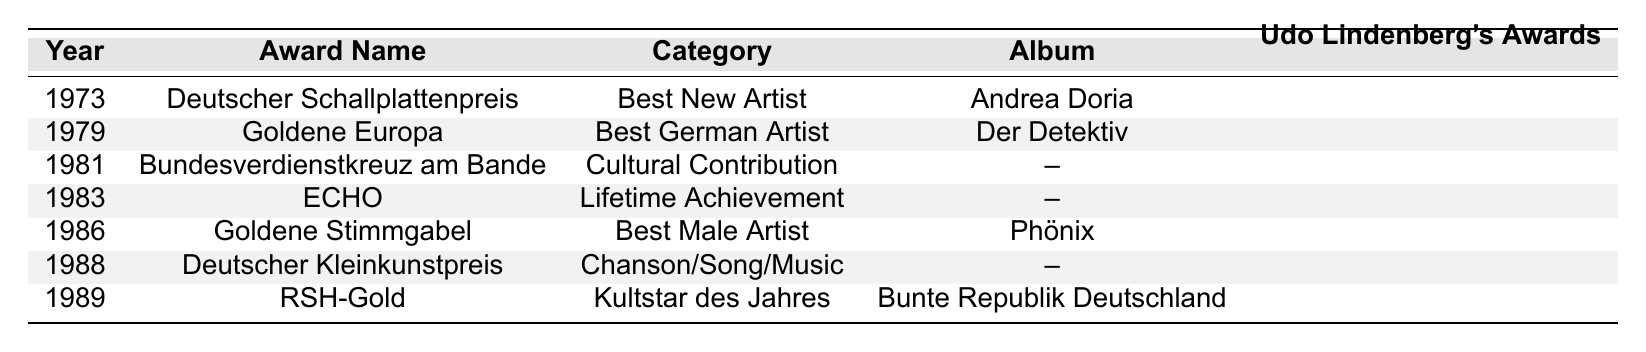What award did Udo Lindenberg receive in 1973? According to the table, in 1973, Udo Lindenberg received the "Deutscher Schallplattenpreis" for "Best New Artist."
Answer: Deutscher Schallplattenpreis How many awards did Udo Lindenberg receive in the 1980s? The table lists Udo Lindenberg receiving four awards in the 1980s: 1981 (Bundesverdienstkreuz am Bande), 1983 (ECHO), 1986 (Goldene Stimmgabel), and 1988 (Deutscher Kleinkunstpreis).
Answer: Four awards Which award did Udo Lindenberg win for the album "Bunte Republik Deutschland"? Udo Lindenberg received the "RSH-Gold" for "Kultstar des Jahres" in 1989 for the album "Bunte Republik Deutschland."
Answer: RSH-Gold What is the category of the award received in 1986? The award received in 1986 is the "Goldene Stimmgabel" under the category "Best Male Artist."
Answer: Best Male Artist In which year did Udo Lindenberg receive an award for "Cultural Contribution"? Udo Lindenberg received an award for "Cultural Contribution" in 1981, specifically the "Bundesverdienstkreuz am Bande."
Answer: 1981 How many awards did Udo Lindenberg win for specific albums until 1990? Udo Lindenberg won awards for three specific albums: "Andrea Doria" (1973), "Der Detektiv" (1979), and "Phönix" (1986), totaling three albums.
Answer: Three albums Was there any award in 1988, and if so, what was it for? Yes, in 1988, Udo Lindenberg received the "Deutscher Kleinkunstpreis" for the category "Chanson/Song/Music."
Answer: Yes, Deutscher Kleinkunstpreis Which award signifies Udo Lindenberg's "Lifetime Achievement"? The "ECHO" award, given in 1983, signifies Udo Lindenberg's "Lifetime Achievement."
Answer: ECHO Calculate the total number of awards Udo Lindenberg received from 1973 to 1990. According to the table, Udo Lindenberg received a total of seven awards listed from 1973 to 1989, meaning he received seven awards total until 1990.
Answer: Seven awards Which award did he receive first? The first award Udo Lindenberg received is the "Deutscher Schallplattenpreis" in 1973.
Answer: Deutscher Schallplattenpreis 